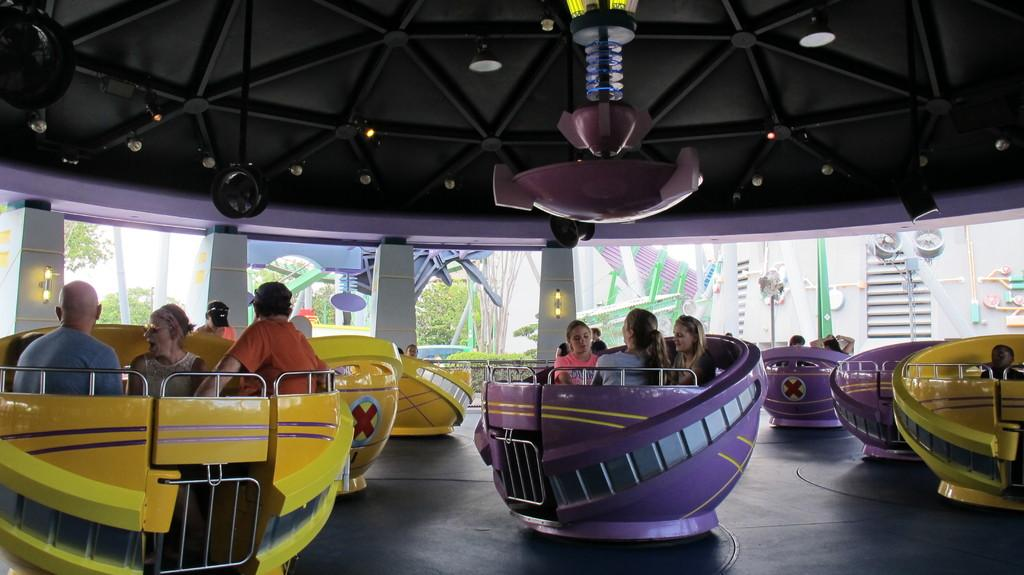Who or what can be seen in the image? There are people in the image. What are the people doing in the image? The people are sitting in a cup-shaped amusement ride. What type of voice can be heard coming from the seashore in the image? There is no seashore or voice present in the image; it features people sitting in a cup-shaped amusement ride. 